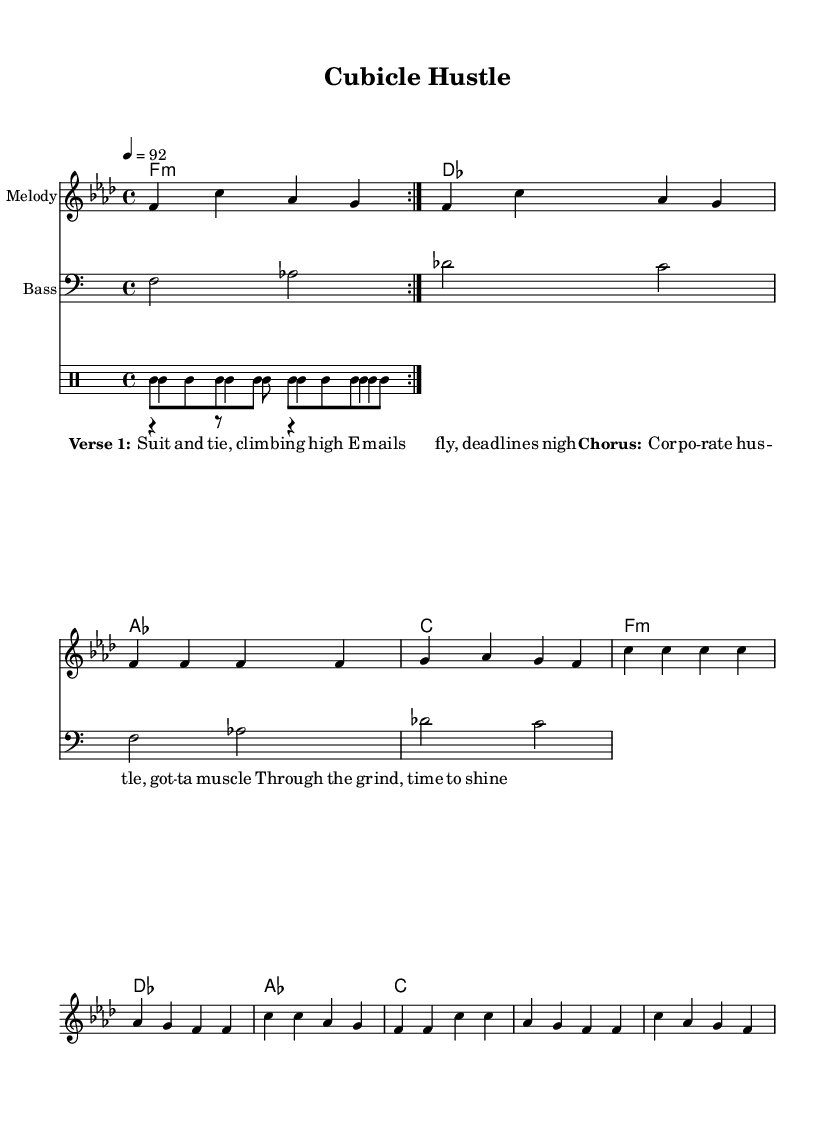What is the key signature of this music? The key signature at the beginning of the score is marked with a flat sign before the staff, indicating that it is in the key of F minor.
Answer: F minor What is the time signature of this piece? The time signature written at the beginning of the score is 4/4, which means there are four beats per measure. This is indicated by the notation after the key signature.
Answer: 4/4 What is the tempo marking for this music? The tempo marking displayed at the beginning states "4 = 92", which indicates the speed at which the music should be played, with the quarter note equal to 92 beats per minute.
Answer: 92 How many measures are in the verse section? By counting the measures in the verse part of the melody, which is clearly indicated in the score, we see there are 4 measures.
Answer: 4 What is the main theme of the lyrics? Analyzing the lyrics provided within the score, the overarching theme reflects the struggle and determination in a corporate environment. The words highlight the hustle to succeed while managing deadlines and responsibilities.
Answer: Corporate hustle What instruments are included in this score? By looking through the different parts listed in the score, we see sections for Melody, Bass, and a DrumStaff indicating the percussion instruments involved. The distinct parts indicate the variety of instruments used in this piece.
Answer: Melody, Bass, Drums What type of musical structure is observed in this rap? The organization of the lyrics and melody into distinct sections labeled as "Verse" and "Chorus" depicts a structure commonly found in rap and hip-hop music, emphasizing repetitive themes making it catchy.
Answer: Verse and Chorus 